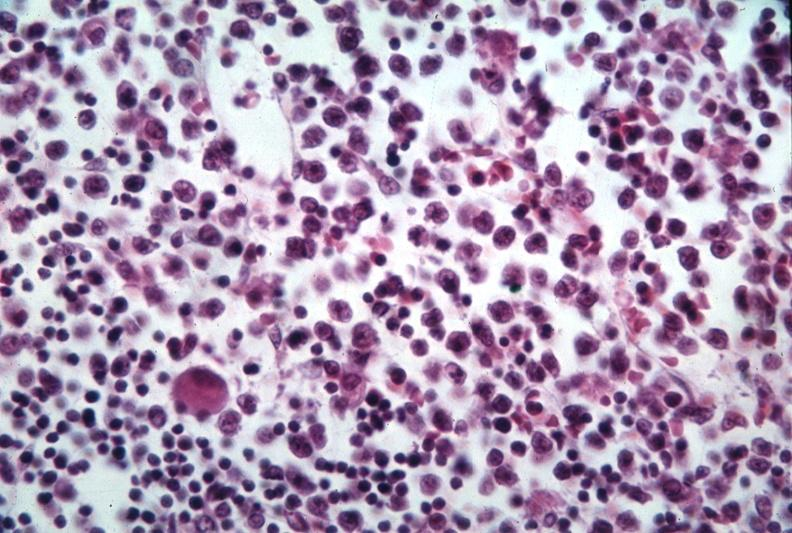s hematologic present?
Answer the question using a single word or phrase. Yes 